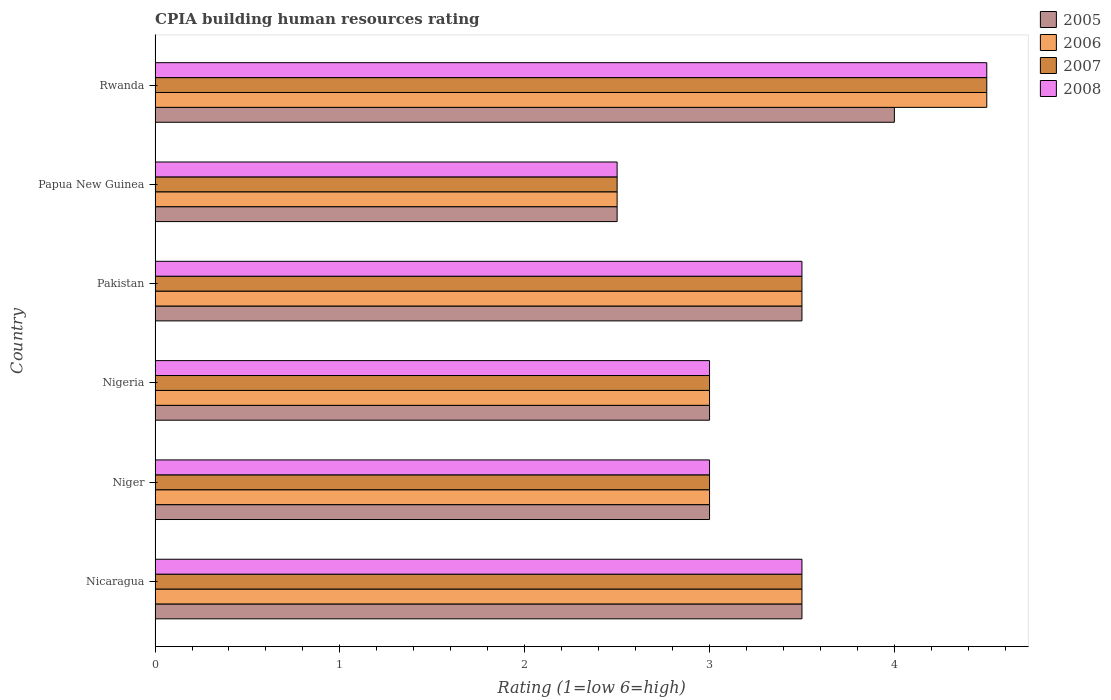Are the number of bars per tick equal to the number of legend labels?
Your response must be concise. Yes. Are the number of bars on each tick of the Y-axis equal?
Offer a very short reply. Yes. How many bars are there on the 5th tick from the top?
Give a very brief answer. 4. What is the label of the 4th group of bars from the top?
Ensure brevity in your answer.  Nigeria. What is the CPIA rating in 2006 in Pakistan?
Your response must be concise. 3.5. In which country was the CPIA rating in 2005 maximum?
Your answer should be compact. Rwanda. In which country was the CPIA rating in 2005 minimum?
Ensure brevity in your answer.  Papua New Guinea. What is the total CPIA rating in 2008 in the graph?
Your response must be concise. 20. What is the difference between the CPIA rating in 2005 in Nigeria and the CPIA rating in 2008 in Nicaragua?
Your response must be concise. -0.5. What is the average CPIA rating in 2006 per country?
Provide a short and direct response. 3.33. Is the CPIA rating in 2008 in Nicaragua less than that in Nigeria?
Give a very brief answer. No. What is the difference between the highest and the second highest CPIA rating in 2005?
Your answer should be compact. 0.5. What is the difference between the highest and the lowest CPIA rating in 2005?
Your response must be concise. 1.5. In how many countries, is the CPIA rating in 2005 greater than the average CPIA rating in 2005 taken over all countries?
Keep it short and to the point. 3. Is it the case that in every country, the sum of the CPIA rating in 2005 and CPIA rating in 2006 is greater than the sum of CPIA rating in 2007 and CPIA rating in 2008?
Offer a very short reply. No. What does the 1st bar from the top in Rwanda represents?
Provide a succinct answer. 2008. What does the 3rd bar from the bottom in Papua New Guinea represents?
Offer a terse response. 2007. How many bars are there?
Your answer should be very brief. 24. Does the graph contain any zero values?
Your response must be concise. No. Does the graph contain grids?
Make the answer very short. No. Where does the legend appear in the graph?
Your response must be concise. Top right. How are the legend labels stacked?
Provide a succinct answer. Vertical. What is the title of the graph?
Your answer should be very brief. CPIA building human resources rating. What is the label or title of the X-axis?
Offer a terse response. Rating (1=low 6=high). What is the Rating (1=low 6=high) of 2005 in Nicaragua?
Give a very brief answer. 3.5. What is the Rating (1=low 6=high) in 2008 in Nicaragua?
Ensure brevity in your answer.  3.5. What is the Rating (1=low 6=high) of 2005 in Niger?
Your answer should be very brief. 3. What is the Rating (1=low 6=high) of 2007 in Niger?
Offer a terse response. 3. What is the Rating (1=low 6=high) in 2007 in Nigeria?
Keep it short and to the point. 3. What is the Rating (1=low 6=high) in 2005 in Pakistan?
Give a very brief answer. 3.5. What is the Rating (1=low 6=high) of 2007 in Pakistan?
Offer a terse response. 3.5. What is the Rating (1=low 6=high) in 2008 in Pakistan?
Provide a succinct answer. 3.5. What is the Rating (1=low 6=high) in 2005 in Papua New Guinea?
Offer a terse response. 2.5. What is the Rating (1=low 6=high) of 2007 in Papua New Guinea?
Provide a succinct answer. 2.5. What is the Rating (1=low 6=high) in 2005 in Rwanda?
Give a very brief answer. 4. What is the Rating (1=low 6=high) in 2008 in Rwanda?
Ensure brevity in your answer.  4.5. Across all countries, what is the maximum Rating (1=low 6=high) of 2006?
Provide a succinct answer. 4.5. Across all countries, what is the maximum Rating (1=low 6=high) in 2007?
Provide a succinct answer. 4.5. Across all countries, what is the maximum Rating (1=low 6=high) in 2008?
Offer a very short reply. 4.5. What is the total Rating (1=low 6=high) in 2005 in the graph?
Your answer should be compact. 19.5. What is the total Rating (1=low 6=high) of 2006 in the graph?
Provide a short and direct response. 20. What is the total Rating (1=low 6=high) of 2007 in the graph?
Your response must be concise. 20. What is the total Rating (1=low 6=high) in 2008 in the graph?
Provide a short and direct response. 20. What is the difference between the Rating (1=low 6=high) of 2005 in Nicaragua and that in Niger?
Offer a very short reply. 0.5. What is the difference between the Rating (1=low 6=high) in 2006 in Nicaragua and that in Niger?
Keep it short and to the point. 0.5. What is the difference between the Rating (1=low 6=high) in 2007 in Nicaragua and that in Niger?
Make the answer very short. 0.5. What is the difference between the Rating (1=low 6=high) of 2008 in Nicaragua and that in Nigeria?
Provide a short and direct response. 0.5. What is the difference between the Rating (1=low 6=high) in 2007 in Nicaragua and that in Pakistan?
Your answer should be compact. 0. What is the difference between the Rating (1=low 6=high) of 2005 in Nicaragua and that in Papua New Guinea?
Offer a very short reply. 1. What is the difference between the Rating (1=low 6=high) in 2008 in Nicaragua and that in Papua New Guinea?
Your response must be concise. 1. What is the difference between the Rating (1=low 6=high) in 2005 in Nicaragua and that in Rwanda?
Make the answer very short. -0.5. What is the difference between the Rating (1=low 6=high) of 2007 in Nicaragua and that in Rwanda?
Keep it short and to the point. -1. What is the difference between the Rating (1=low 6=high) of 2008 in Nicaragua and that in Rwanda?
Provide a succinct answer. -1. What is the difference between the Rating (1=low 6=high) of 2005 in Niger and that in Nigeria?
Make the answer very short. 0. What is the difference between the Rating (1=low 6=high) in 2006 in Niger and that in Nigeria?
Make the answer very short. 0. What is the difference between the Rating (1=low 6=high) of 2007 in Niger and that in Nigeria?
Offer a very short reply. 0. What is the difference between the Rating (1=low 6=high) of 2006 in Niger and that in Pakistan?
Provide a short and direct response. -0.5. What is the difference between the Rating (1=low 6=high) in 2008 in Niger and that in Pakistan?
Your answer should be compact. -0.5. What is the difference between the Rating (1=low 6=high) of 2006 in Niger and that in Papua New Guinea?
Your answer should be compact. 0.5. What is the difference between the Rating (1=low 6=high) of 2007 in Niger and that in Papua New Guinea?
Offer a very short reply. 0.5. What is the difference between the Rating (1=low 6=high) of 2006 in Niger and that in Rwanda?
Your answer should be very brief. -1.5. What is the difference between the Rating (1=low 6=high) in 2007 in Niger and that in Rwanda?
Offer a very short reply. -1.5. What is the difference between the Rating (1=low 6=high) of 2005 in Nigeria and that in Pakistan?
Your answer should be compact. -0.5. What is the difference between the Rating (1=low 6=high) in 2005 in Nigeria and that in Papua New Guinea?
Give a very brief answer. 0.5. What is the difference between the Rating (1=low 6=high) in 2008 in Nigeria and that in Papua New Guinea?
Your answer should be very brief. 0.5. What is the difference between the Rating (1=low 6=high) of 2006 in Nigeria and that in Rwanda?
Your response must be concise. -1.5. What is the difference between the Rating (1=low 6=high) of 2007 in Nigeria and that in Rwanda?
Your answer should be very brief. -1.5. What is the difference between the Rating (1=low 6=high) of 2005 in Pakistan and that in Papua New Guinea?
Offer a terse response. 1. What is the difference between the Rating (1=low 6=high) in 2006 in Pakistan and that in Papua New Guinea?
Give a very brief answer. 1. What is the difference between the Rating (1=low 6=high) in 2005 in Pakistan and that in Rwanda?
Give a very brief answer. -0.5. What is the difference between the Rating (1=low 6=high) of 2006 in Pakistan and that in Rwanda?
Your answer should be very brief. -1. What is the difference between the Rating (1=low 6=high) in 2006 in Papua New Guinea and that in Rwanda?
Offer a terse response. -2. What is the difference between the Rating (1=low 6=high) in 2007 in Papua New Guinea and that in Rwanda?
Your answer should be compact. -2. What is the difference between the Rating (1=low 6=high) of 2005 in Nicaragua and the Rating (1=low 6=high) of 2006 in Niger?
Your response must be concise. 0.5. What is the difference between the Rating (1=low 6=high) in 2005 in Nicaragua and the Rating (1=low 6=high) in 2007 in Niger?
Ensure brevity in your answer.  0.5. What is the difference between the Rating (1=low 6=high) in 2006 in Nicaragua and the Rating (1=low 6=high) in 2008 in Niger?
Give a very brief answer. 0.5. What is the difference between the Rating (1=low 6=high) of 2005 in Nicaragua and the Rating (1=low 6=high) of 2007 in Nigeria?
Keep it short and to the point. 0.5. What is the difference between the Rating (1=low 6=high) in 2006 in Nicaragua and the Rating (1=low 6=high) in 2007 in Nigeria?
Your answer should be very brief. 0.5. What is the difference between the Rating (1=low 6=high) of 2006 in Nicaragua and the Rating (1=low 6=high) of 2008 in Nigeria?
Provide a succinct answer. 0.5. What is the difference between the Rating (1=low 6=high) in 2007 in Nicaragua and the Rating (1=low 6=high) in 2008 in Nigeria?
Provide a succinct answer. 0.5. What is the difference between the Rating (1=low 6=high) in 2005 in Nicaragua and the Rating (1=low 6=high) in 2007 in Pakistan?
Provide a succinct answer. 0. What is the difference between the Rating (1=low 6=high) in 2006 in Nicaragua and the Rating (1=low 6=high) in 2008 in Pakistan?
Ensure brevity in your answer.  0. What is the difference between the Rating (1=low 6=high) of 2005 in Nicaragua and the Rating (1=low 6=high) of 2006 in Papua New Guinea?
Ensure brevity in your answer.  1. What is the difference between the Rating (1=low 6=high) of 2006 in Nicaragua and the Rating (1=low 6=high) of 2007 in Papua New Guinea?
Make the answer very short. 1. What is the difference between the Rating (1=low 6=high) of 2007 in Nicaragua and the Rating (1=low 6=high) of 2008 in Papua New Guinea?
Provide a succinct answer. 1. What is the difference between the Rating (1=low 6=high) of 2005 in Nicaragua and the Rating (1=low 6=high) of 2006 in Rwanda?
Offer a terse response. -1. What is the difference between the Rating (1=low 6=high) in 2005 in Nicaragua and the Rating (1=low 6=high) in 2008 in Rwanda?
Ensure brevity in your answer.  -1. What is the difference between the Rating (1=low 6=high) of 2006 in Nicaragua and the Rating (1=low 6=high) of 2007 in Rwanda?
Offer a terse response. -1. What is the difference between the Rating (1=low 6=high) in 2006 in Nicaragua and the Rating (1=low 6=high) in 2008 in Rwanda?
Make the answer very short. -1. What is the difference between the Rating (1=low 6=high) in 2007 in Nicaragua and the Rating (1=low 6=high) in 2008 in Rwanda?
Ensure brevity in your answer.  -1. What is the difference between the Rating (1=low 6=high) in 2005 in Niger and the Rating (1=low 6=high) in 2007 in Nigeria?
Give a very brief answer. 0. What is the difference between the Rating (1=low 6=high) of 2005 in Niger and the Rating (1=low 6=high) of 2008 in Nigeria?
Your response must be concise. 0. What is the difference between the Rating (1=low 6=high) in 2007 in Niger and the Rating (1=low 6=high) in 2008 in Nigeria?
Give a very brief answer. 0. What is the difference between the Rating (1=low 6=high) of 2005 in Niger and the Rating (1=low 6=high) of 2006 in Pakistan?
Give a very brief answer. -0.5. What is the difference between the Rating (1=low 6=high) in 2006 in Niger and the Rating (1=low 6=high) in 2007 in Pakistan?
Provide a short and direct response. -0.5. What is the difference between the Rating (1=low 6=high) in 2005 in Niger and the Rating (1=low 6=high) in 2006 in Papua New Guinea?
Keep it short and to the point. 0.5. What is the difference between the Rating (1=low 6=high) in 2006 in Niger and the Rating (1=low 6=high) in 2007 in Papua New Guinea?
Your response must be concise. 0.5. What is the difference between the Rating (1=low 6=high) of 2007 in Niger and the Rating (1=low 6=high) of 2008 in Papua New Guinea?
Offer a very short reply. 0.5. What is the difference between the Rating (1=low 6=high) in 2005 in Niger and the Rating (1=low 6=high) in 2007 in Rwanda?
Offer a terse response. -1.5. What is the difference between the Rating (1=low 6=high) of 2005 in Niger and the Rating (1=low 6=high) of 2008 in Rwanda?
Ensure brevity in your answer.  -1.5. What is the difference between the Rating (1=low 6=high) in 2006 in Niger and the Rating (1=low 6=high) in 2007 in Rwanda?
Provide a short and direct response. -1.5. What is the difference between the Rating (1=low 6=high) in 2007 in Niger and the Rating (1=low 6=high) in 2008 in Rwanda?
Provide a succinct answer. -1.5. What is the difference between the Rating (1=low 6=high) in 2005 in Nigeria and the Rating (1=low 6=high) in 2006 in Pakistan?
Offer a very short reply. -0.5. What is the difference between the Rating (1=low 6=high) in 2005 in Nigeria and the Rating (1=low 6=high) in 2007 in Pakistan?
Offer a very short reply. -0.5. What is the difference between the Rating (1=low 6=high) in 2006 in Nigeria and the Rating (1=low 6=high) in 2007 in Pakistan?
Provide a short and direct response. -0.5. What is the difference between the Rating (1=low 6=high) of 2006 in Nigeria and the Rating (1=low 6=high) of 2008 in Pakistan?
Offer a terse response. -0.5. What is the difference between the Rating (1=low 6=high) of 2007 in Nigeria and the Rating (1=low 6=high) of 2008 in Pakistan?
Your response must be concise. -0.5. What is the difference between the Rating (1=low 6=high) of 2005 in Nigeria and the Rating (1=low 6=high) of 2007 in Papua New Guinea?
Provide a short and direct response. 0.5. What is the difference between the Rating (1=low 6=high) of 2005 in Nigeria and the Rating (1=low 6=high) of 2006 in Rwanda?
Make the answer very short. -1.5. What is the difference between the Rating (1=low 6=high) of 2006 in Nigeria and the Rating (1=low 6=high) of 2007 in Rwanda?
Offer a very short reply. -1.5. What is the difference between the Rating (1=low 6=high) in 2006 in Nigeria and the Rating (1=low 6=high) in 2008 in Rwanda?
Make the answer very short. -1.5. What is the difference between the Rating (1=low 6=high) in 2007 in Nigeria and the Rating (1=low 6=high) in 2008 in Rwanda?
Offer a very short reply. -1.5. What is the difference between the Rating (1=low 6=high) of 2005 in Pakistan and the Rating (1=low 6=high) of 2006 in Papua New Guinea?
Keep it short and to the point. 1. What is the difference between the Rating (1=low 6=high) in 2005 in Pakistan and the Rating (1=low 6=high) in 2007 in Papua New Guinea?
Your answer should be compact. 1. What is the difference between the Rating (1=low 6=high) of 2005 in Pakistan and the Rating (1=low 6=high) of 2008 in Papua New Guinea?
Make the answer very short. 1. What is the difference between the Rating (1=low 6=high) in 2006 in Pakistan and the Rating (1=low 6=high) in 2007 in Papua New Guinea?
Provide a succinct answer. 1. What is the difference between the Rating (1=low 6=high) of 2007 in Pakistan and the Rating (1=low 6=high) of 2008 in Papua New Guinea?
Make the answer very short. 1. What is the difference between the Rating (1=low 6=high) in 2006 in Pakistan and the Rating (1=low 6=high) in 2007 in Rwanda?
Ensure brevity in your answer.  -1. What is the difference between the Rating (1=low 6=high) in 2005 in Papua New Guinea and the Rating (1=low 6=high) in 2007 in Rwanda?
Offer a terse response. -2. What is the difference between the Rating (1=low 6=high) in 2005 in Papua New Guinea and the Rating (1=low 6=high) in 2008 in Rwanda?
Ensure brevity in your answer.  -2. What is the difference between the Rating (1=low 6=high) of 2007 in Papua New Guinea and the Rating (1=low 6=high) of 2008 in Rwanda?
Give a very brief answer. -2. What is the average Rating (1=low 6=high) in 2005 per country?
Provide a succinct answer. 3.25. What is the difference between the Rating (1=low 6=high) of 2005 and Rating (1=low 6=high) of 2006 in Nicaragua?
Make the answer very short. 0. What is the difference between the Rating (1=low 6=high) of 2005 and Rating (1=low 6=high) of 2007 in Nicaragua?
Give a very brief answer. 0. What is the difference between the Rating (1=low 6=high) in 2006 and Rating (1=low 6=high) in 2008 in Nicaragua?
Make the answer very short. 0. What is the difference between the Rating (1=low 6=high) in 2005 and Rating (1=low 6=high) in 2006 in Niger?
Keep it short and to the point. 0. What is the difference between the Rating (1=low 6=high) in 2007 and Rating (1=low 6=high) in 2008 in Niger?
Your response must be concise. 0. What is the difference between the Rating (1=low 6=high) in 2005 and Rating (1=low 6=high) in 2006 in Pakistan?
Offer a very short reply. 0. What is the difference between the Rating (1=low 6=high) in 2005 and Rating (1=low 6=high) in 2007 in Pakistan?
Your answer should be very brief. 0. What is the difference between the Rating (1=low 6=high) in 2006 and Rating (1=low 6=high) in 2008 in Pakistan?
Provide a short and direct response. 0. What is the difference between the Rating (1=low 6=high) of 2005 and Rating (1=low 6=high) of 2007 in Papua New Guinea?
Offer a terse response. 0. What is the difference between the Rating (1=low 6=high) in 2005 and Rating (1=low 6=high) in 2008 in Papua New Guinea?
Provide a succinct answer. 0. What is the difference between the Rating (1=low 6=high) of 2006 and Rating (1=low 6=high) of 2007 in Papua New Guinea?
Offer a very short reply. 0. What is the difference between the Rating (1=low 6=high) in 2007 and Rating (1=low 6=high) in 2008 in Papua New Guinea?
Your answer should be very brief. 0. What is the difference between the Rating (1=low 6=high) in 2005 and Rating (1=low 6=high) in 2007 in Rwanda?
Your answer should be compact. -0.5. What is the difference between the Rating (1=low 6=high) in 2005 and Rating (1=low 6=high) in 2008 in Rwanda?
Offer a terse response. -0.5. What is the difference between the Rating (1=low 6=high) of 2006 and Rating (1=low 6=high) of 2008 in Rwanda?
Keep it short and to the point. 0. What is the difference between the Rating (1=low 6=high) of 2007 and Rating (1=low 6=high) of 2008 in Rwanda?
Ensure brevity in your answer.  0. What is the ratio of the Rating (1=low 6=high) in 2005 in Nicaragua to that in Niger?
Your answer should be compact. 1.17. What is the ratio of the Rating (1=low 6=high) in 2008 in Nicaragua to that in Niger?
Offer a terse response. 1.17. What is the ratio of the Rating (1=low 6=high) in 2008 in Nicaragua to that in Pakistan?
Keep it short and to the point. 1. What is the ratio of the Rating (1=low 6=high) of 2005 in Nicaragua to that in Papua New Guinea?
Offer a terse response. 1.4. What is the ratio of the Rating (1=low 6=high) of 2006 in Nicaragua to that in Papua New Guinea?
Ensure brevity in your answer.  1.4. What is the ratio of the Rating (1=low 6=high) of 2006 in Nicaragua to that in Rwanda?
Offer a very short reply. 0.78. What is the ratio of the Rating (1=low 6=high) in 2007 in Nicaragua to that in Rwanda?
Offer a terse response. 0.78. What is the ratio of the Rating (1=low 6=high) of 2005 in Niger to that in Nigeria?
Give a very brief answer. 1. What is the ratio of the Rating (1=low 6=high) in 2006 in Niger to that in Pakistan?
Provide a short and direct response. 0.86. What is the ratio of the Rating (1=low 6=high) in 2008 in Niger to that in Pakistan?
Provide a succinct answer. 0.86. What is the ratio of the Rating (1=low 6=high) in 2005 in Niger to that in Papua New Guinea?
Your answer should be very brief. 1.2. What is the ratio of the Rating (1=low 6=high) of 2006 in Niger to that in Papua New Guinea?
Offer a terse response. 1.2. What is the ratio of the Rating (1=low 6=high) in 2008 in Niger to that in Papua New Guinea?
Your answer should be very brief. 1.2. What is the ratio of the Rating (1=low 6=high) in 2006 in Nigeria to that in Pakistan?
Give a very brief answer. 0.86. What is the ratio of the Rating (1=low 6=high) in 2008 in Nigeria to that in Pakistan?
Keep it short and to the point. 0.86. What is the ratio of the Rating (1=low 6=high) of 2006 in Nigeria to that in Papua New Guinea?
Provide a succinct answer. 1.2. What is the ratio of the Rating (1=low 6=high) in 2008 in Nigeria to that in Rwanda?
Ensure brevity in your answer.  0.67. What is the ratio of the Rating (1=low 6=high) in 2005 in Pakistan to that in Papua New Guinea?
Give a very brief answer. 1.4. What is the ratio of the Rating (1=low 6=high) in 2008 in Pakistan to that in Papua New Guinea?
Ensure brevity in your answer.  1.4. What is the ratio of the Rating (1=low 6=high) of 2006 in Pakistan to that in Rwanda?
Offer a very short reply. 0.78. What is the ratio of the Rating (1=low 6=high) in 2006 in Papua New Guinea to that in Rwanda?
Provide a succinct answer. 0.56. What is the ratio of the Rating (1=low 6=high) of 2007 in Papua New Guinea to that in Rwanda?
Offer a terse response. 0.56. What is the ratio of the Rating (1=low 6=high) in 2008 in Papua New Guinea to that in Rwanda?
Offer a terse response. 0.56. What is the difference between the highest and the second highest Rating (1=low 6=high) in 2005?
Keep it short and to the point. 0.5. What is the difference between the highest and the second highest Rating (1=low 6=high) in 2006?
Offer a terse response. 1. What is the difference between the highest and the second highest Rating (1=low 6=high) of 2007?
Your response must be concise. 1. What is the difference between the highest and the lowest Rating (1=low 6=high) in 2007?
Provide a short and direct response. 2. 